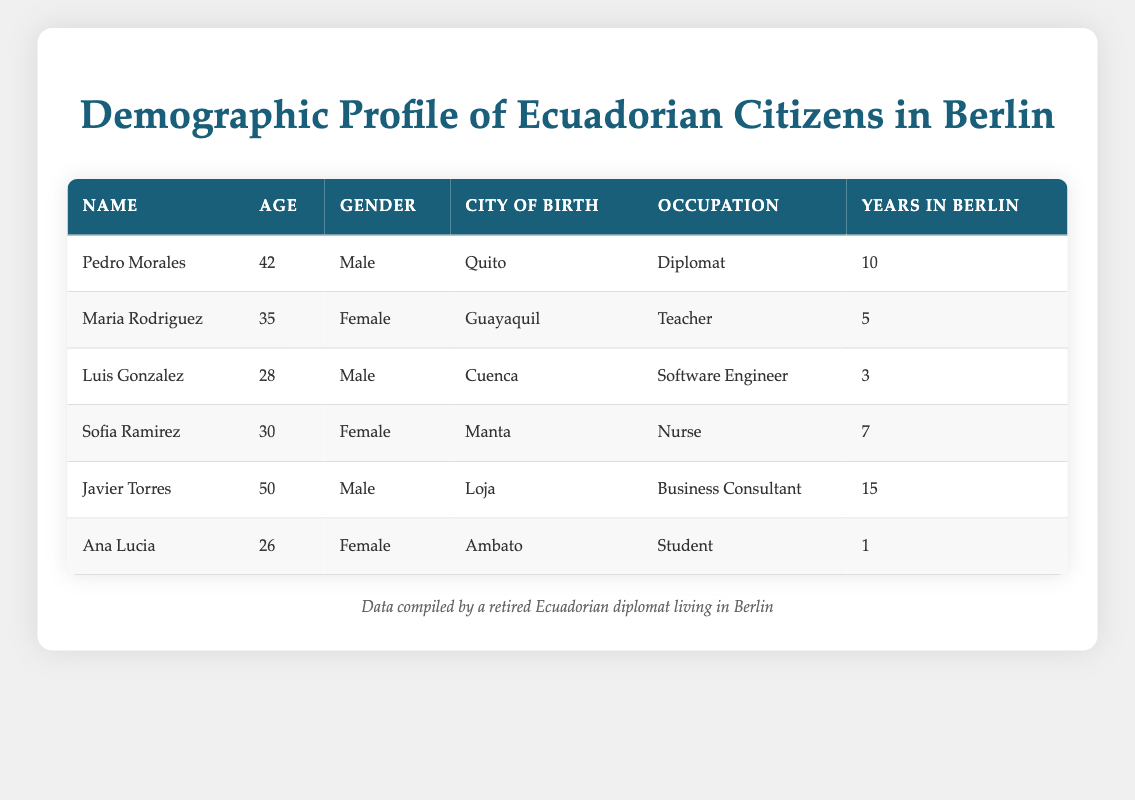What is the age of Maria Rodriguez? The table lists Maria Rodriguez's details under the "Age" column, which shows the value as 35.
Answer: 35 How many Ecuadorian citizens listed have lived in Berlin for more than 10 years? By examining the "Years in Berlin" column, we see that only Javier Torres (15 years) and Pedro Morales (10 years) are mentioned. However, since the question specifies more than 10 years, only Javier Torres qualifies.
Answer: 1 What is the occupation of Luis Gonzalez? The table indicates Luis Gonzalez's profession under the "Occupation" column, which states he is a Software Engineer.
Answer: Software Engineer What is the average age of the Ecuadorian citizens in the table? The ages listed are 42, 35, 28, 30, 50, and 26. To find the average, we sum these ages: 42 + 35 + 28 + 30 + 50 + 26 = 211. There are 6 individuals, so the average age is 211 divided by 6, which equals approximately 35.17.
Answer: 35.17 Are there any Ecuadorian citizens in the table who are students? By reviewing the "Occupation" column, we find that Ana Lucia is listed as a Student, confirming that there is at least one student among the Ecuadorian citizens.
Answer: Yes How many males are listed in the table? The "Gender" column indicates the genders of the individuals. Pedro Morales, Luis Gonzalez, and Javier Torres are the males, totaling three.
Answer: 3 What city does Sofia Ramirez originate from? The "City of Birth" column specifies Sofia Ramirez was born in Manta.
Answer: Manta What is the total number of years lived in Berlin by all the individuals combined? Summing the "Years in Berlin": 10 + 5 + 3 + 7 + 15 + 1 = 41 years. This gives us the total number of years lived in Berlin for all the Ecuadorian citizens listed.
Answer: 41 Among the individuals listed, is there anyone who is 30 years old or younger? Reviewing the "Age" column, we find that Luis Gonzalez (28) and Ana Lucia (26) are both 30 years old or younger, confirming the existence of individuals in this age range.
Answer: Yes 